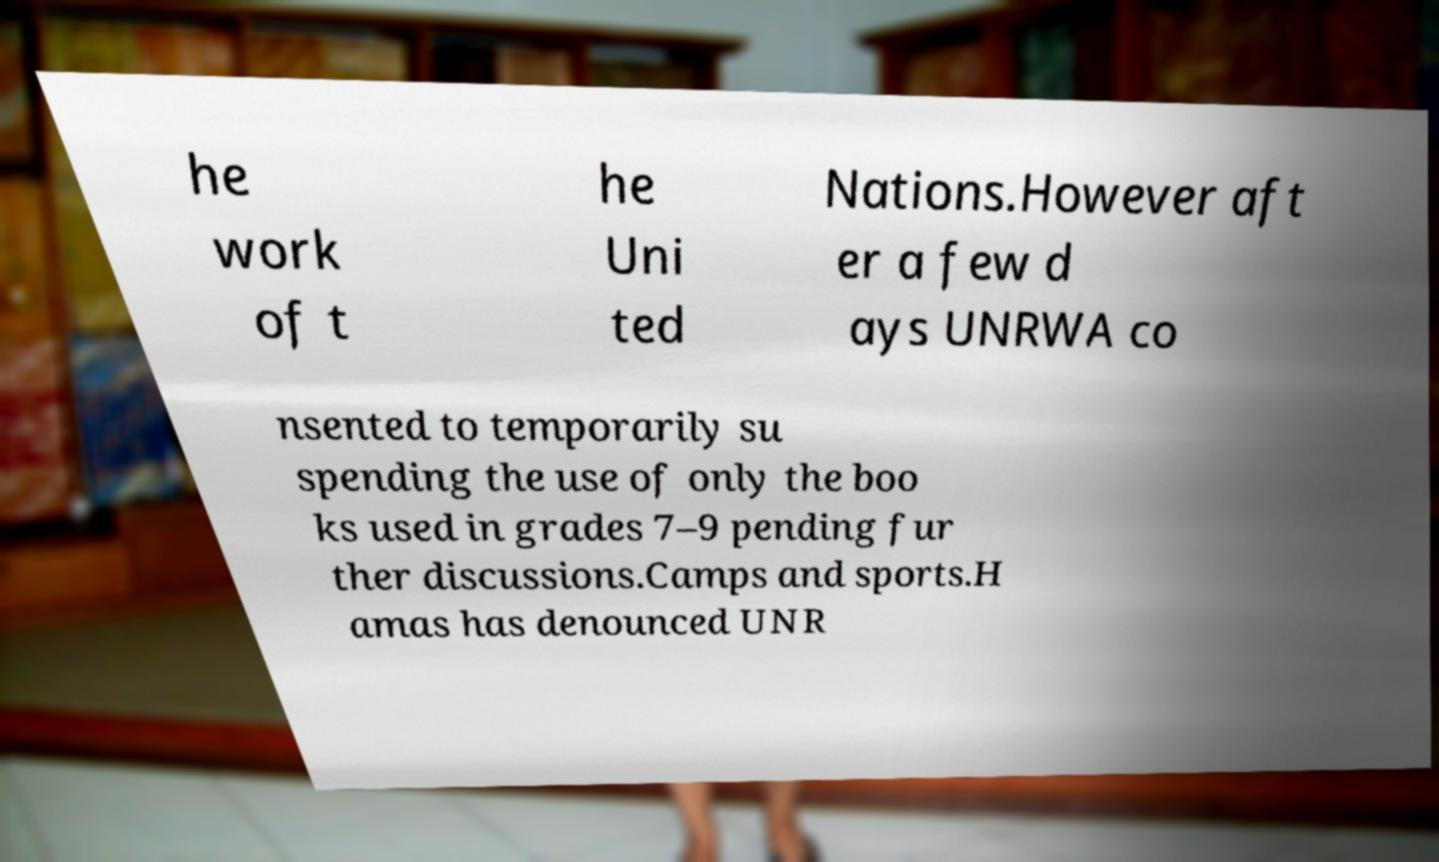Could you extract and type out the text from this image? he work of t he Uni ted Nations.However aft er a few d ays UNRWA co nsented to temporarily su spending the use of only the boo ks used in grades 7–9 pending fur ther discussions.Camps and sports.H amas has denounced UNR 